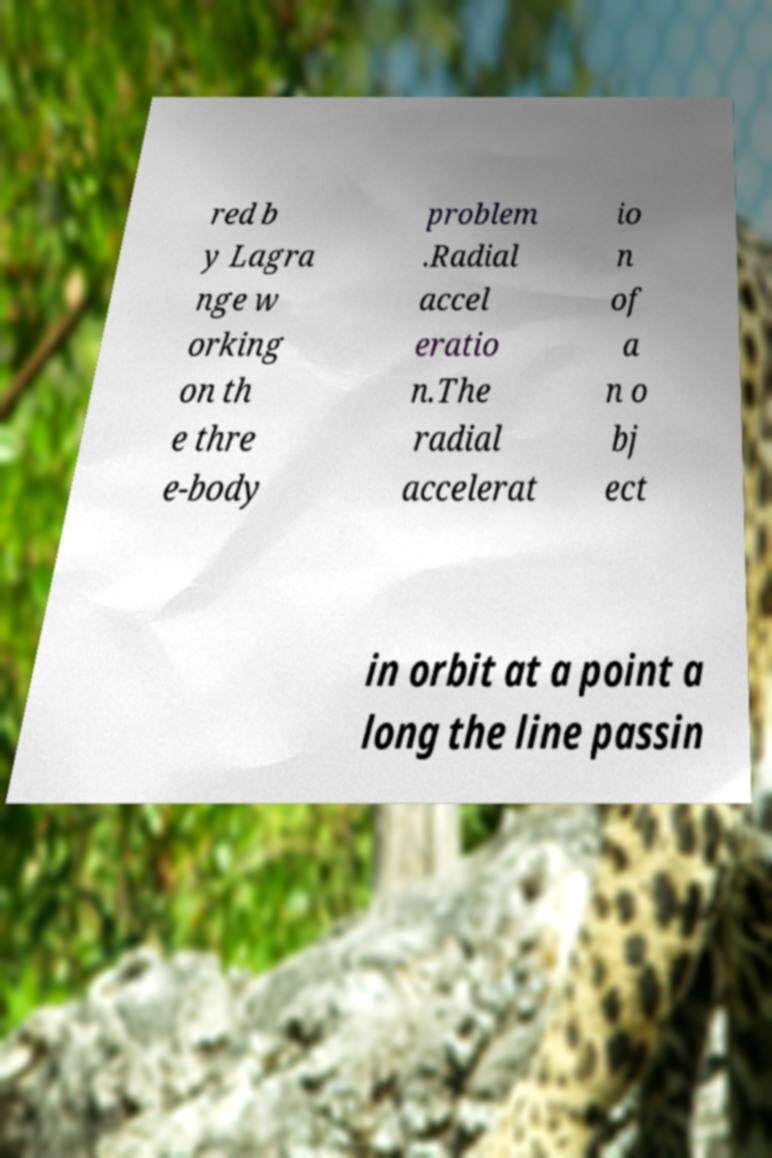I need the written content from this picture converted into text. Can you do that? red b y Lagra nge w orking on th e thre e-body problem .Radial accel eratio n.The radial accelerat io n of a n o bj ect in orbit at a point a long the line passin 